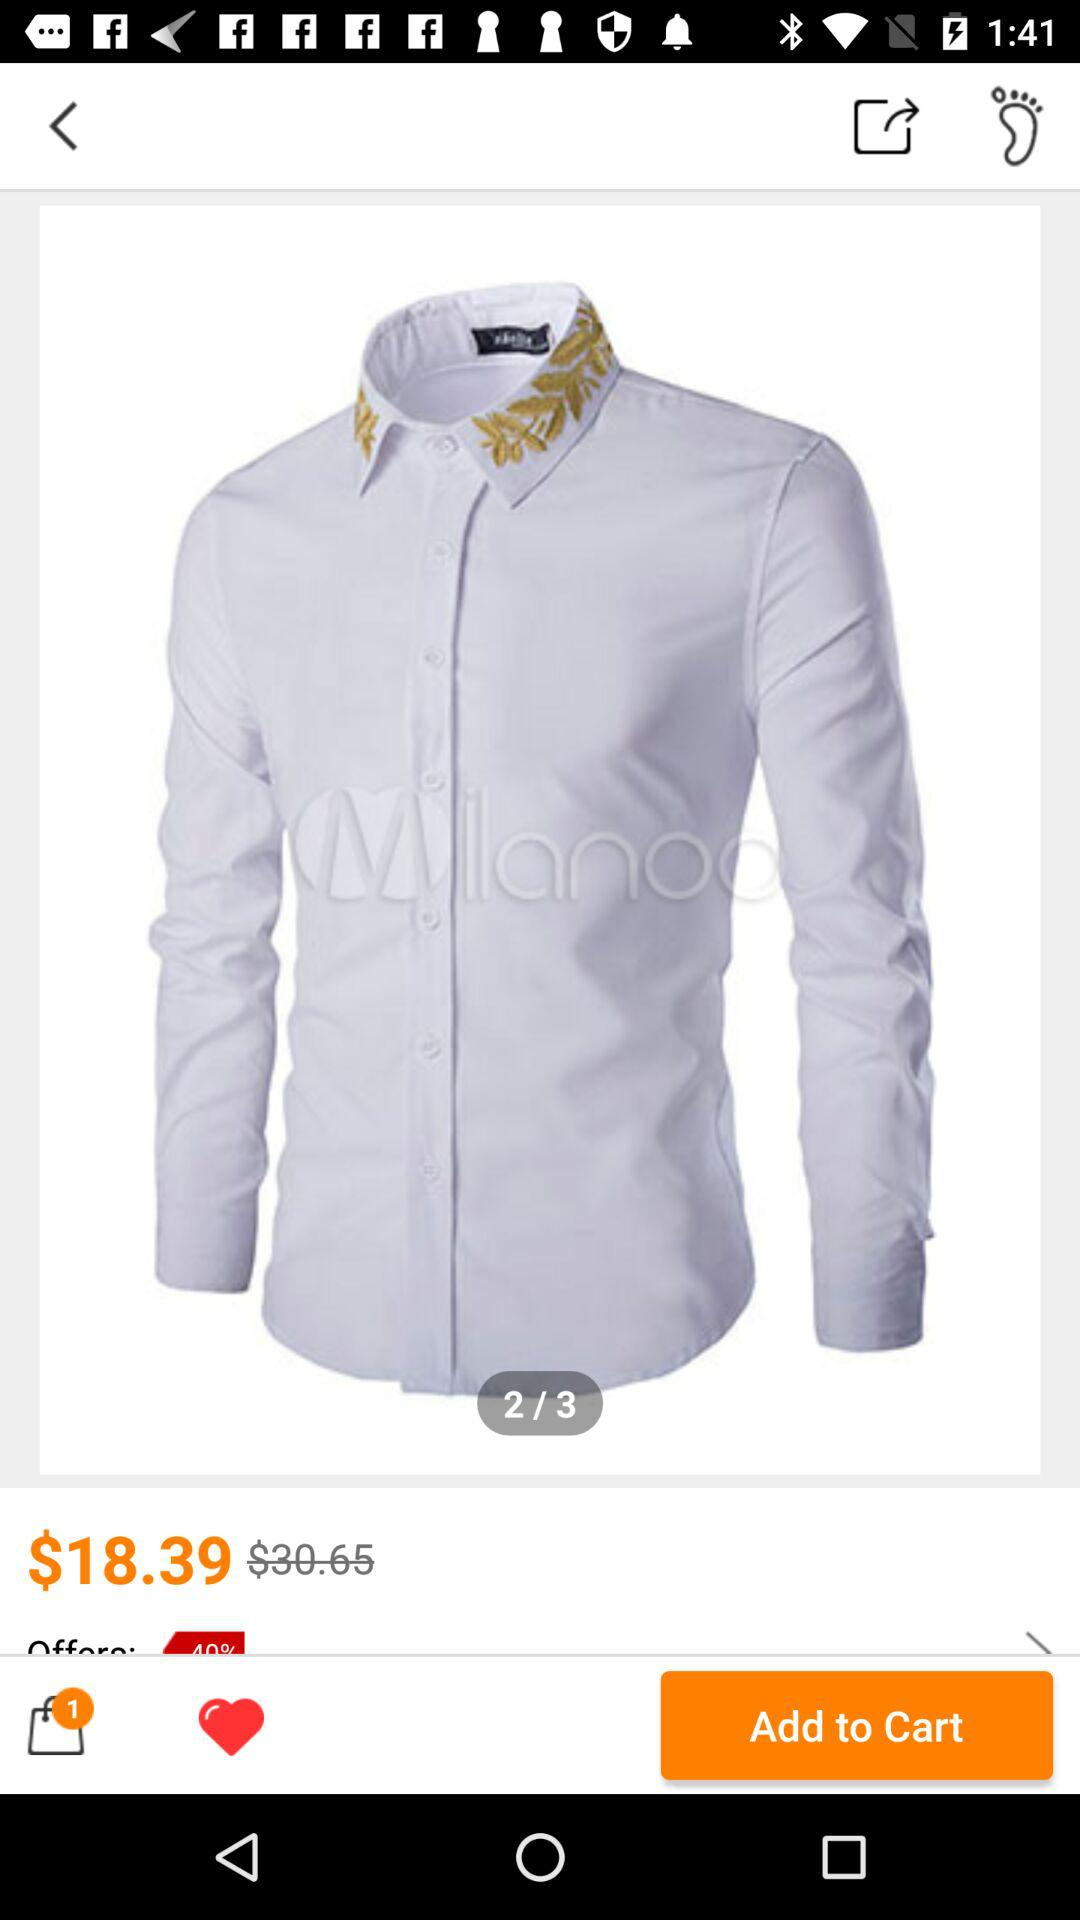How much more does the shirt cost than it is marked down?
Answer the question using a single word or phrase. $12.26 